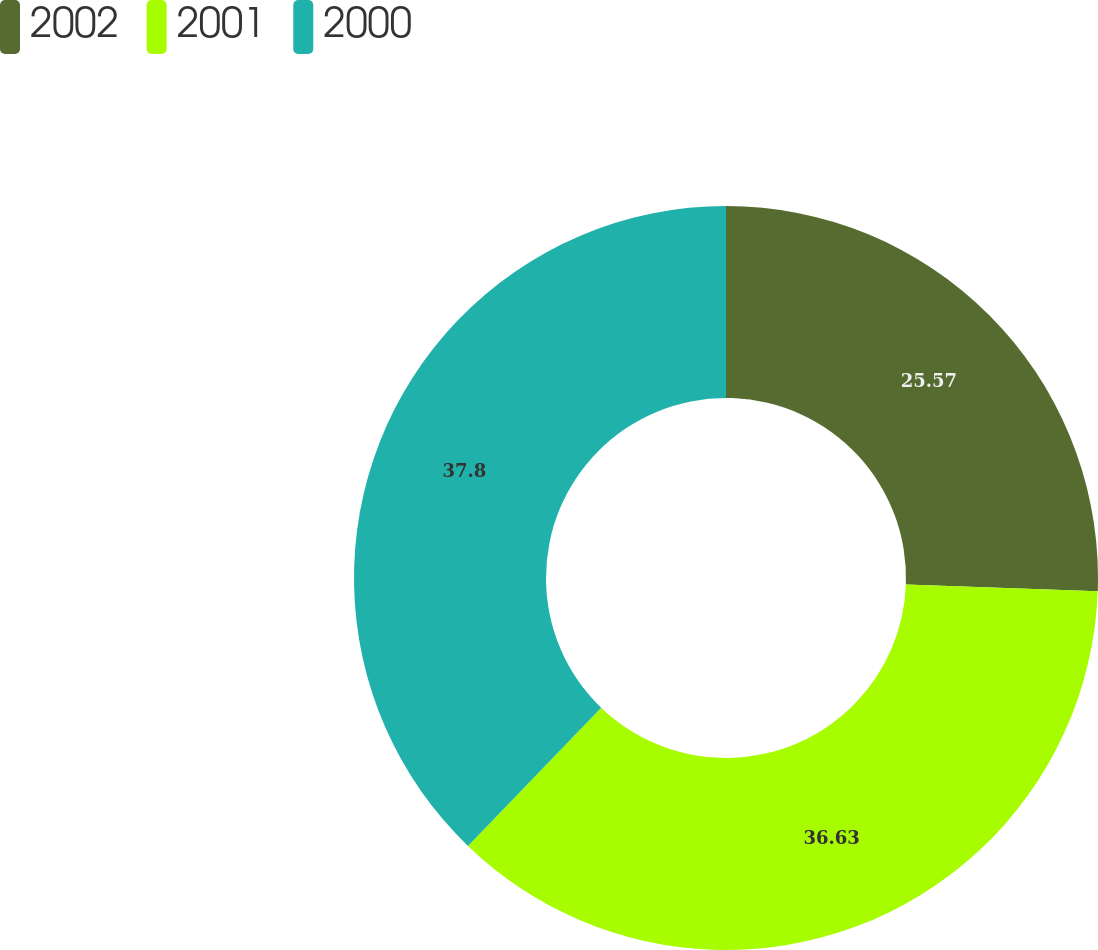Convert chart. <chart><loc_0><loc_0><loc_500><loc_500><pie_chart><fcel>2002<fcel>2001<fcel>2000<nl><fcel>25.57%<fcel>36.63%<fcel>37.8%<nl></chart> 